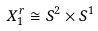Convert formula to latex. <formula><loc_0><loc_0><loc_500><loc_500>X _ { 1 } ^ { r } \cong S ^ { 2 } \times S ^ { 1 }</formula> 